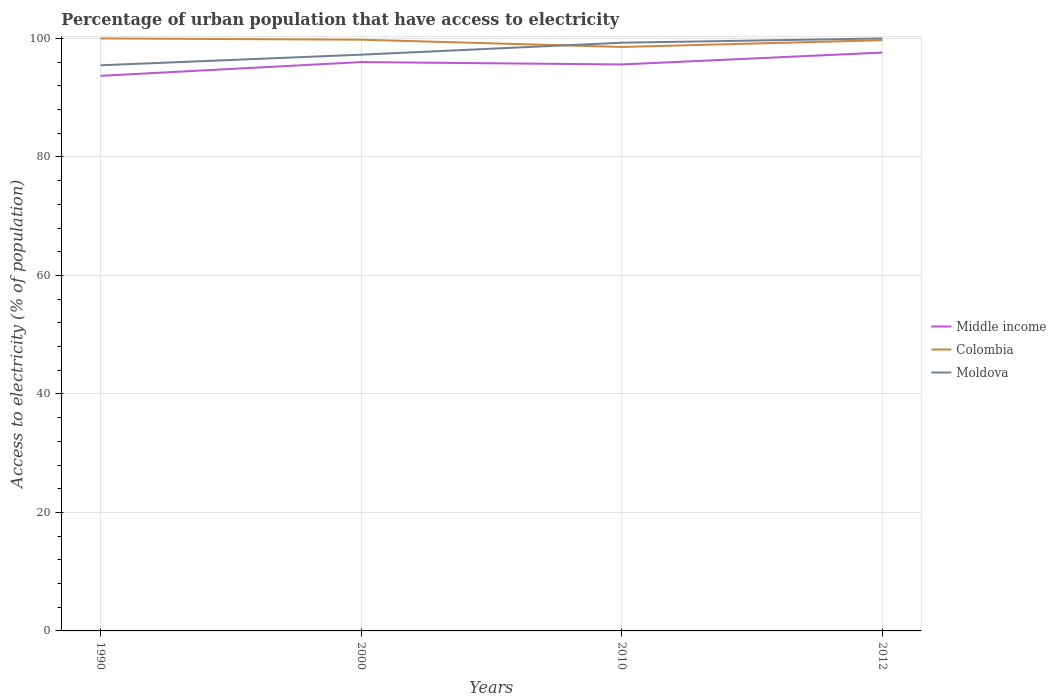How many different coloured lines are there?
Provide a succinct answer. 3. Is the number of lines equal to the number of legend labels?
Keep it short and to the point. Yes. Across all years, what is the maximum percentage of urban population that have access to electricity in Moldova?
Your response must be concise. 95.47. In which year was the percentage of urban population that have access to electricity in Moldova maximum?
Your response must be concise. 1990. What is the total percentage of urban population that have access to electricity in Colombia in the graph?
Offer a very short reply. 0.21. What is the difference between the highest and the second highest percentage of urban population that have access to electricity in Moldova?
Offer a terse response. 4.53. Is the percentage of urban population that have access to electricity in Middle income strictly greater than the percentage of urban population that have access to electricity in Moldova over the years?
Your answer should be compact. Yes. How many lines are there?
Offer a terse response. 3. Does the graph contain any zero values?
Your response must be concise. No. Where does the legend appear in the graph?
Provide a succinct answer. Center right. How many legend labels are there?
Your answer should be compact. 3. How are the legend labels stacked?
Offer a terse response. Vertical. What is the title of the graph?
Make the answer very short. Percentage of urban population that have access to electricity. Does "Uruguay" appear as one of the legend labels in the graph?
Provide a short and direct response. No. What is the label or title of the X-axis?
Ensure brevity in your answer.  Years. What is the label or title of the Y-axis?
Ensure brevity in your answer.  Access to electricity (% of population). What is the Access to electricity (% of population) of Middle income in 1990?
Keep it short and to the point. 93.69. What is the Access to electricity (% of population) of Moldova in 1990?
Make the answer very short. 95.47. What is the Access to electricity (% of population) of Middle income in 2000?
Your response must be concise. 96.01. What is the Access to electricity (% of population) in Colombia in 2000?
Ensure brevity in your answer.  99.79. What is the Access to electricity (% of population) in Moldova in 2000?
Your response must be concise. 97.26. What is the Access to electricity (% of population) in Middle income in 2010?
Keep it short and to the point. 95.61. What is the Access to electricity (% of population) of Colombia in 2010?
Provide a succinct answer. 98.56. What is the Access to electricity (% of population) of Moldova in 2010?
Your response must be concise. 99.28. What is the Access to electricity (% of population) of Middle income in 2012?
Offer a terse response. 97.62. What is the Access to electricity (% of population) in Colombia in 2012?
Your answer should be very brief. 99.7. What is the Access to electricity (% of population) of Moldova in 2012?
Provide a short and direct response. 100. Across all years, what is the maximum Access to electricity (% of population) in Middle income?
Offer a terse response. 97.62. Across all years, what is the maximum Access to electricity (% of population) in Moldova?
Your answer should be compact. 100. Across all years, what is the minimum Access to electricity (% of population) in Middle income?
Provide a short and direct response. 93.69. Across all years, what is the minimum Access to electricity (% of population) in Colombia?
Offer a very short reply. 98.56. Across all years, what is the minimum Access to electricity (% of population) in Moldova?
Provide a short and direct response. 95.47. What is the total Access to electricity (% of population) in Middle income in the graph?
Provide a short and direct response. 382.93. What is the total Access to electricity (% of population) in Colombia in the graph?
Offer a very short reply. 398.05. What is the total Access to electricity (% of population) in Moldova in the graph?
Provide a short and direct response. 392.01. What is the difference between the Access to electricity (% of population) of Middle income in 1990 and that in 2000?
Provide a succinct answer. -2.32. What is the difference between the Access to electricity (% of population) in Colombia in 1990 and that in 2000?
Provide a succinct answer. 0.21. What is the difference between the Access to electricity (% of population) in Moldova in 1990 and that in 2000?
Your answer should be compact. -1.8. What is the difference between the Access to electricity (% of population) of Middle income in 1990 and that in 2010?
Offer a very short reply. -1.92. What is the difference between the Access to electricity (% of population) of Colombia in 1990 and that in 2010?
Offer a terse response. 1.44. What is the difference between the Access to electricity (% of population) of Moldova in 1990 and that in 2010?
Your answer should be very brief. -3.81. What is the difference between the Access to electricity (% of population) of Middle income in 1990 and that in 2012?
Keep it short and to the point. -3.93. What is the difference between the Access to electricity (% of population) in Moldova in 1990 and that in 2012?
Keep it short and to the point. -4.53. What is the difference between the Access to electricity (% of population) in Middle income in 2000 and that in 2010?
Your response must be concise. 0.4. What is the difference between the Access to electricity (% of population) of Colombia in 2000 and that in 2010?
Your answer should be compact. 1.22. What is the difference between the Access to electricity (% of population) of Moldova in 2000 and that in 2010?
Provide a succinct answer. -2.02. What is the difference between the Access to electricity (% of population) in Middle income in 2000 and that in 2012?
Offer a very short reply. -1.61. What is the difference between the Access to electricity (% of population) of Colombia in 2000 and that in 2012?
Offer a terse response. 0.09. What is the difference between the Access to electricity (% of population) of Moldova in 2000 and that in 2012?
Your response must be concise. -2.74. What is the difference between the Access to electricity (% of population) in Middle income in 2010 and that in 2012?
Provide a short and direct response. -2.01. What is the difference between the Access to electricity (% of population) of Colombia in 2010 and that in 2012?
Make the answer very short. -1.14. What is the difference between the Access to electricity (% of population) of Moldova in 2010 and that in 2012?
Give a very brief answer. -0.72. What is the difference between the Access to electricity (% of population) in Middle income in 1990 and the Access to electricity (% of population) in Colombia in 2000?
Your response must be concise. -6.1. What is the difference between the Access to electricity (% of population) of Middle income in 1990 and the Access to electricity (% of population) of Moldova in 2000?
Offer a very short reply. -3.57. What is the difference between the Access to electricity (% of population) in Colombia in 1990 and the Access to electricity (% of population) in Moldova in 2000?
Ensure brevity in your answer.  2.74. What is the difference between the Access to electricity (% of population) in Middle income in 1990 and the Access to electricity (% of population) in Colombia in 2010?
Keep it short and to the point. -4.87. What is the difference between the Access to electricity (% of population) in Middle income in 1990 and the Access to electricity (% of population) in Moldova in 2010?
Keep it short and to the point. -5.59. What is the difference between the Access to electricity (% of population) of Colombia in 1990 and the Access to electricity (% of population) of Moldova in 2010?
Provide a succinct answer. 0.72. What is the difference between the Access to electricity (% of population) in Middle income in 1990 and the Access to electricity (% of population) in Colombia in 2012?
Provide a short and direct response. -6.01. What is the difference between the Access to electricity (% of population) in Middle income in 1990 and the Access to electricity (% of population) in Moldova in 2012?
Your answer should be compact. -6.31. What is the difference between the Access to electricity (% of population) in Colombia in 1990 and the Access to electricity (% of population) in Moldova in 2012?
Your response must be concise. 0. What is the difference between the Access to electricity (% of population) of Middle income in 2000 and the Access to electricity (% of population) of Colombia in 2010?
Make the answer very short. -2.56. What is the difference between the Access to electricity (% of population) in Middle income in 2000 and the Access to electricity (% of population) in Moldova in 2010?
Make the answer very short. -3.27. What is the difference between the Access to electricity (% of population) in Colombia in 2000 and the Access to electricity (% of population) in Moldova in 2010?
Offer a very short reply. 0.51. What is the difference between the Access to electricity (% of population) in Middle income in 2000 and the Access to electricity (% of population) in Colombia in 2012?
Give a very brief answer. -3.69. What is the difference between the Access to electricity (% of population) of Middle income in 2000 and the Access to electricity (% of population) of Moldova in 2012?
Your answer should be compact. -3.99. What is the difference between the Access to electricity (% of population) of Colombia in 2000 and the Access to electricity (% of population) of Moldova in 2012?
Offer a very short reply. -0.21. What is the difference between the Access to electricity (% of population) in Middle income in 2010 and the Access to electricity (% of population) in Colombia in 2012?
Ensure brevity in your answer.  -4.09. What is the difference between the Access to electricity (% of population) in Middle income in 2010 and the Access to electricity (% of population) in Moldova in 2012?
Keep it short and to the point. -4.39. What is the difference between the Access to electricity (% of population) in Colombia in 2010 and the Access to electricity (% of population) in Moldova in 2012?
Provide a short and direct response. -1.44. What is the average Access to electricity (% of population) in Middle income per year?
Your answer should be compact. 95.73. What is the average Access to electricity (% of population) in Colombia per year?
Your answer should be compact. 99.51. What is the average Access to electricity (% of population) of Moldova per year?
Offer a very short reply. 98. In the year 1990, what is the difference between the Access to electricity (% of population) in Middle income and Access to electricity (% of population) in Colombia?
Make the answer very short. -6.31. In the year 1990, what is the difference between the Access to electricity (% of population) of Middle income and Access to electricity (% of population) of Moldova?
Provide a short and direct response. -1.78. In the year 1990, what is the difference between the Access to electricity (% of population) in Colombia and Access to electricity (% of population) in Moldova?
Keep it short and to the point. 4.53. In the year 2000, what is the difference between the Access to electricity (% of population) in Middle income and Access to electricity (% of population) in Colombia?
Provide a succinct answer. -3.78. In the year 2000, what is the difference between the Access to electricity (% of population) in Middle income and Access to electricity (% of population) in Moldova?
Your response must be concise. -1.25. In the year 2000, what is the difference between the Access to electricity (% of population) of Colombia and Access to electricity (% of population) of Moldova?
Provide a short and direct response. 2.53. In the year 2010, what is the difference between the Access to electricity (% of population) of Middle income and Access to electricity (% of population) of Colombia?
Ensure brevity in your answer.  -2.95. In the year 2010, what is the difference between the Access to electricity (% of population) of Middle income and Access to electricity (% of population) of Moldova?
Offer a terse response. -3.67. In the year 2010, what is the difference between the Access to electricity (% of population) of Colombia and Access to electricity (% of population) of Moldova?
Ensure brevity in your answer.  -0.71. In the year 2012, what is the difference between the Access to electricity (% of population) in Middle income and Access to electricity (% of population) in Colombia?
Your response must be concise. -2.08. In the year 2012, what is the difference between the Access to electricity (% of population) in Middle income and Access to electricity (% of population) in Moldova?
Ensure brevity in your answer.  -2.38. What is the ratio of the Access to electricity (% of population) of Middle income in 1990 to that in 2000?
Provide a short and direct response. 0.98. What is the ratio of the Access to electricity (% of population) of Colombia in 1990 to that in 2000?
Keep it short and to the point. 1. What is the ratio of the Access to electricity (% of population) of Moldova in 1990 to that in 2000?
Your answer should be compact. 0.98. What is the ratio of the Access to electricity (% of population) of Middle income in 1990 to that in 2010?
Your answer should be compact. 0.98. What is the ratio of the Access to electricity (% of population) of Colombia in 1990 to that in 2010?
Offer a very short reply. 1.01. What is the ratio of the Access to electricity (% of population) in Moldova in 1990 to that in 2010?
Your response must be concise. 0.96. What is the ratio of the Access to electricity (% of population) of Middle income in 1990 to that in 2012?
Keep it short and to the point. 0.96. What is the ratio of the Access to electricity (% of population) in Moldova in 1990 to that in 2012?
Your answer should be compact. 0.95. What is the ratio of the Access to electricity (% of population) of Colombia in 2000 to that in 2010?
Ensure brevity in your answer.  1.01. What is the ratio of the Access to electricity (% of population) in Moldova in 2000 to that in 2010?
Your answer should be very brief. 0.98. What is the ratio of the Access to electricity (% of population) in Middle income in 2000 to that in 2012?
Provide a succinct answer. 0.98. What is the ratio of the Access to electricity (% of population) in Moldova in 2000 to that in 2012?
Provide a short and direct response. 0.97. What is the ratio of the Access to electricity (% of population) of Middle income in 2010 to that in 2012?
Provide a succinct answer. 0.98. What is the difference between the highest and the second highest Access to electricity (% of population) in Middle income?
Your answer should be compact. 1.61. What is the difference between the highest and the second highest Access to electricity (% of population) of Colombia?
Offer a very short reply. 0.21. What is the difference between the highest and the second highest Access to electricity (% of population) of Moldova?
Provide a short and direct response. 0.72. What is the difference between the highest and the lowest Access to electricity (% of population) of Middle income?
Your answer should be compact. 3.93. What is the difference between the highest and the lowest Access to electricity (% of population) of Colombia?
Keep it short and to the point. 1.44. What is the difference between the highest and the lowest Access to electricity (% of population) of Moldova?
Give a very brief answer. 4.53. 